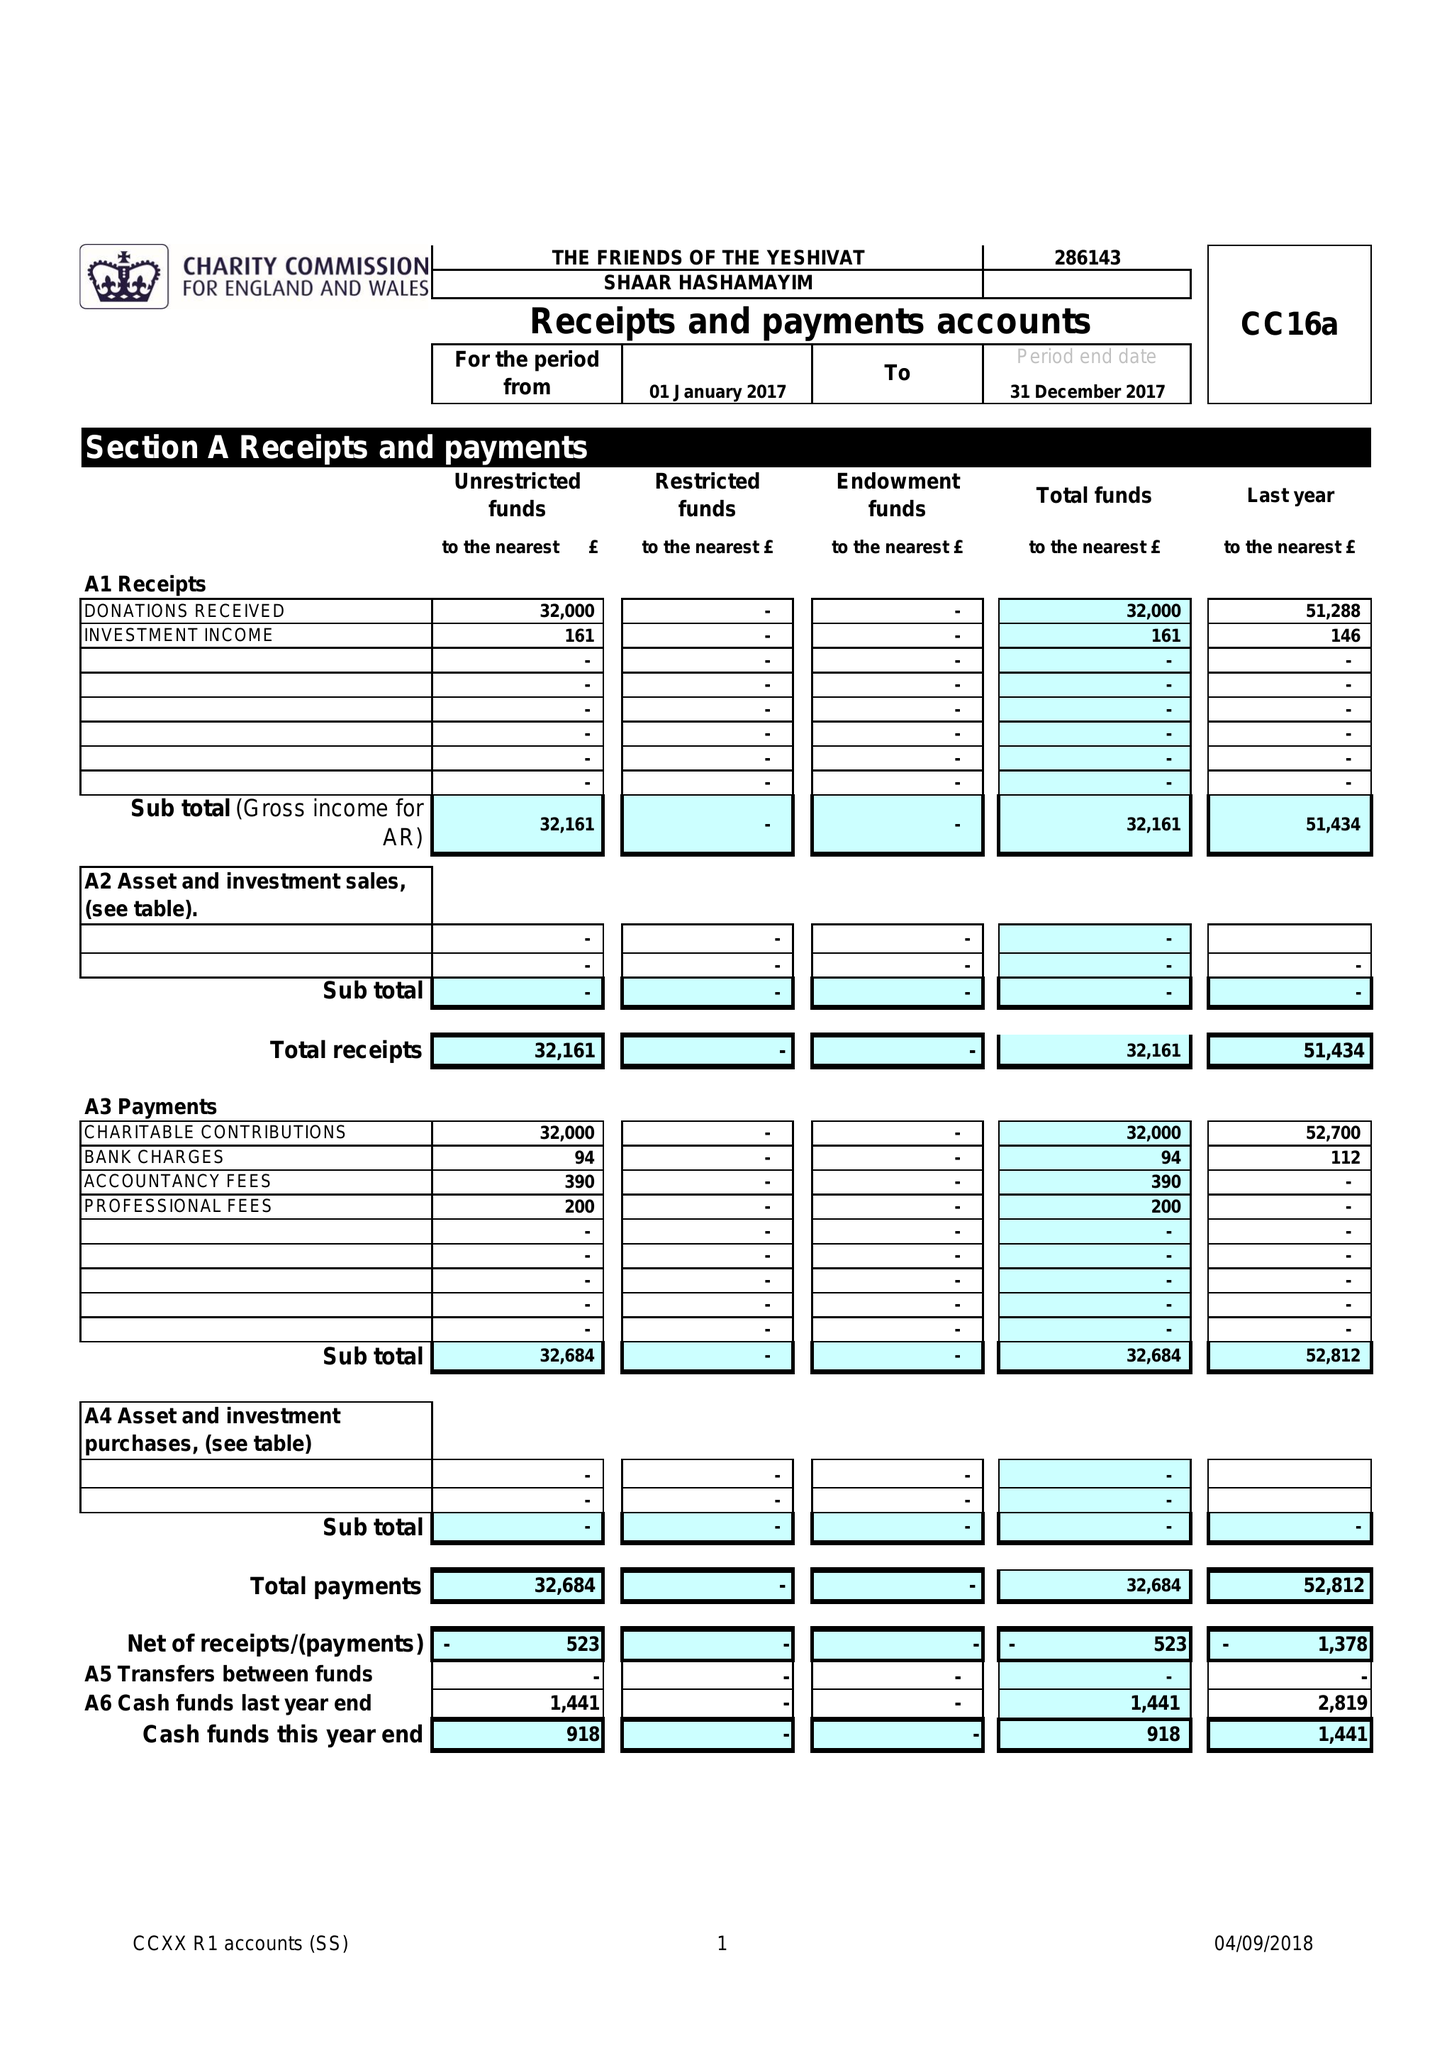What is the value for the address__street_line?
Answer the question using a single word or phrase. 12 DUNSTAN ROAD 